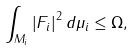Convert formula to latex. <formula><loc_0><loc_0><loc_500><loc_500>\int _ { M _ { i } } \left | F _ { i } \right | ^ { 2 } d \mu _ { i } \leq \Omega ,</formula> 